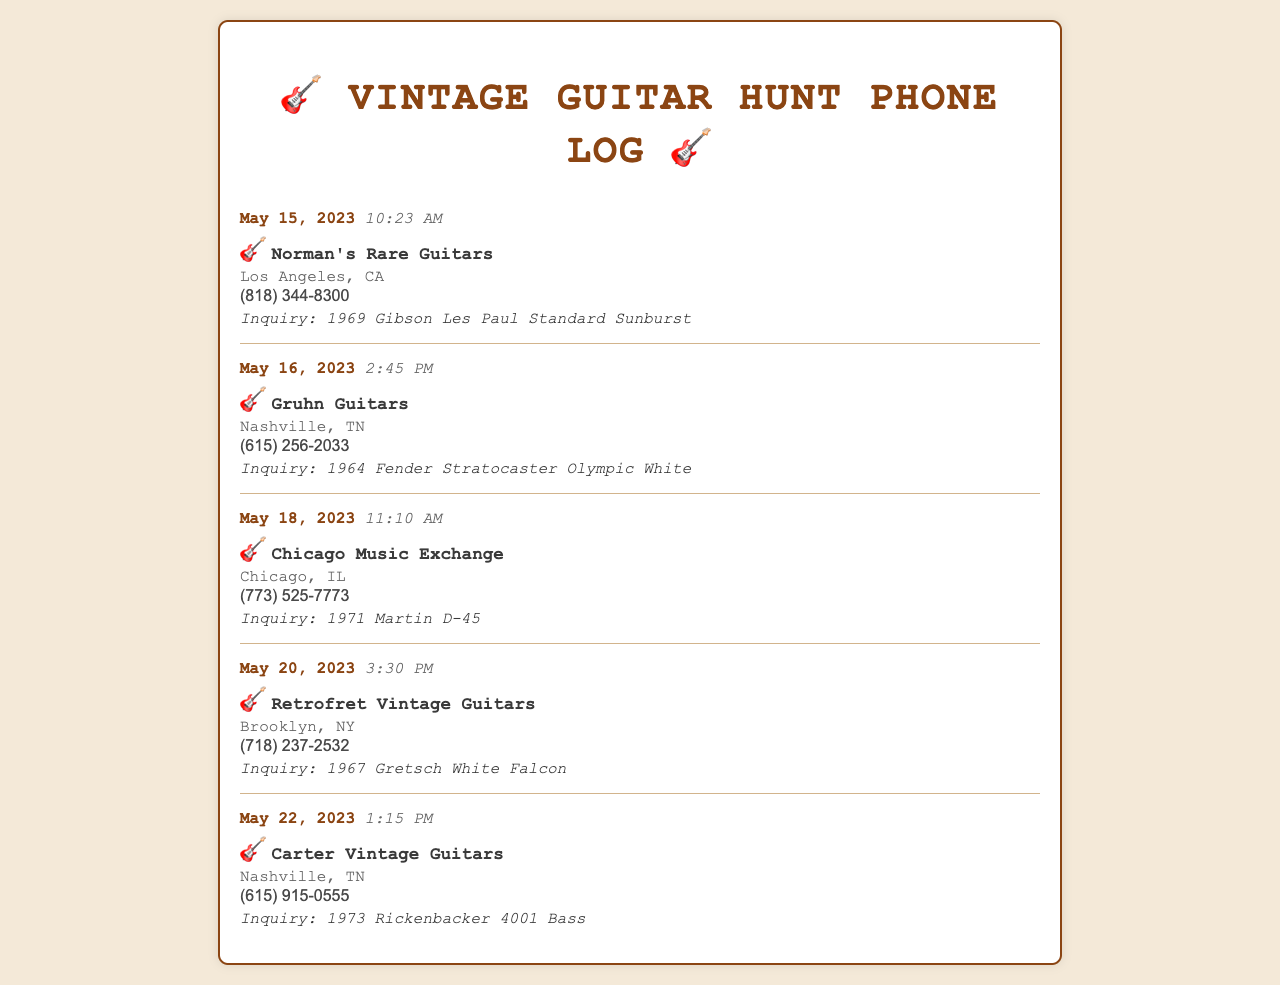what is the date of the first call? The first call was made on May 15, 2023, as shown in the document.
Answer: May 15, 2023 who did the inquiry on May 16, 2023? The inquiry on this date was made to Gruhn Guitars, as indicated in the call log.
Answer: Gruhn Guitars how many calls were made to shops in Nashville? There are two calls listed for shops located in Nashville, TN.
Answer: 2 which guitar was inquired about at Norman's Rare Guitars? The inquiry at Norman's Rare Guitars was about a 1969 Gibson Les Paul Standard Sunburst.
Answer: 1969 Gibson Les Paul Standard Sunburst what was the time of the call to Chicago Music Exchange? The call to Chicago Music Exchange was made at 11:10 AM, according to the log.
Answer: 11:10 AM which shop was contacted last? The shop contacted last was Carter Vintage Guitars on May 22, 2023.
Answer: Carter Vintage Guitars what type of guitar was inquired about at Retrofret Vintage Guitars? The inquiry was about a 1967 Gretsch White Falcon, as stated in the inquiry.
Answer: 1967 Gretsch White Falcon how many different shops were contacted? There are five different shops contacted based on the document records.
Answer: 5 what is the phone number for Chicago Music Exchange? The phone number provided for Chicago Music Exchange is (773) 525-7773.
Answer: (773) 525-7773 